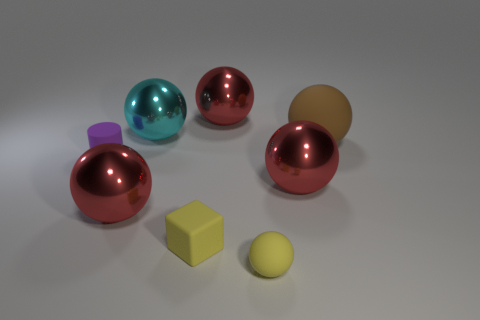Subtract all brown blocks. How many red balls are left? 3 Subtract 2 balls. How many balls are left? 4 Subtract all brown spheres. How many spheres are left? 5 Subtract all small yellow rubber balls. How many balls are left? 5 Subtract all green spheres. Subtract all yellow cylinders. How many spheres are left? 6 Add 2 tiny cylinders. How many objects exist? 10 Subtract all cylinders. How many objects are left? 7 Subtract 0 gray cylinders. How many objects are left? 8 Subtract all big cyan shiny spheres. Subtract all purple rubber cylinders. How many objects are left? 6 Add 7 red things. How many red things are left? 10 